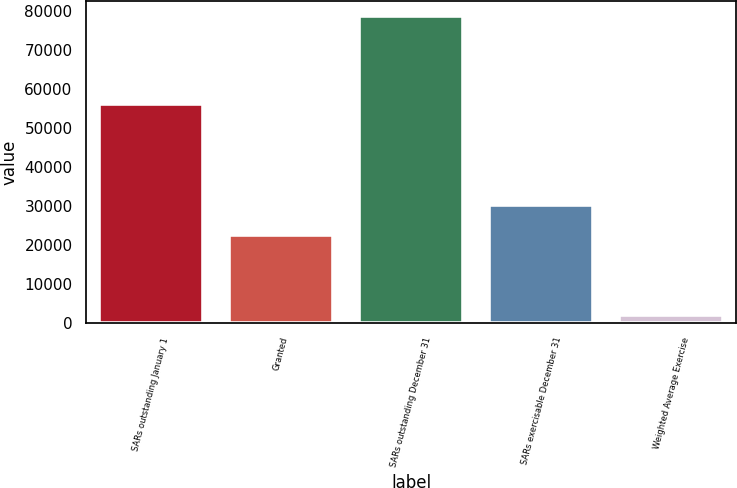<chart> <loc_0><loc_0><loc_500><loc_500><bar_chart><fcel>SARs outstanding January 1<fcel>Granted<fcel>SARs outstanding December 31<fcel>SARs exercisable December 31<fcel>Weighted Average Exercise<nl><fcel>56012<fcel>22500<fcel>78512<fcel>30150.3<fcel>2009<nl></chart> 